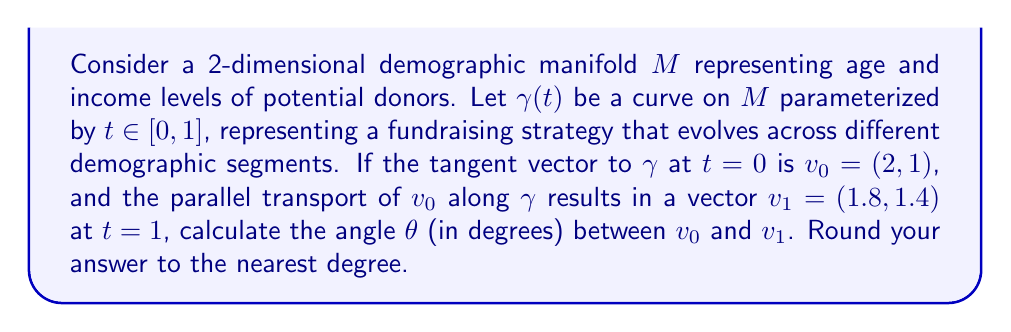Could you help me with this problem? To solve this problem, we'll follow these steps:

1) First, recall that parallel transport preserves the magnitude of vectors. So, $\|v_0\| = \|v_1\|$.

2) Calculate the magnitude of $v_0$:
   $$\|v_0\| = \sqrt{2^2 + 1^2} = \sqrt{5}$$

3) Calculate the dot product of $v_0$ and $v_1$:
   $$v_0 \cdot v_1 = 2(1.8) + 1(1.4) = 3.6 + 1.4 = 5$$

4) Recall the formula for the dot product in terms of magnitudes and angle:
   $$v_0 \cdot v_1 = \|v_0\| \|v_1\| \cos(\theta)$$

5) Substitute the known values:
   $$5 = \sqrt{5} \sqrt{5} \cos(\theta)$$
   $$5 = 5 \cos(\theta)$$

6) Solve for $\theta$:
   $$\cos(\theta) = \frac{5}{5} = 1$$
   $$\theta = \arccos(1) = 0$$

7) Convert to degrees:
   $$\theta = 0° \text{ (rounded to the nearest degree)}$$

This result indicates that the fundraising strategy represented by the curve $\gamma$ maintains its direction relative to the demographic manifold, suggesting consistency across different demographic segments.
Answer: $0°$ 